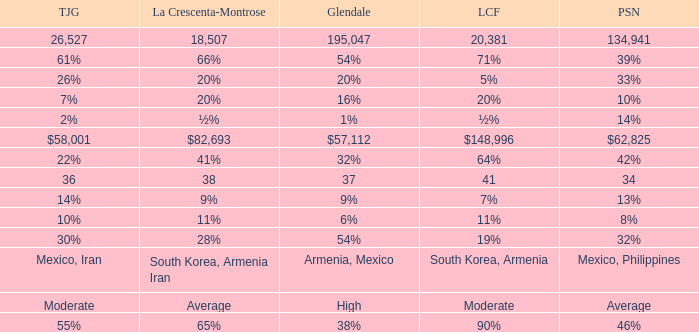What is the percentage of Glendale when La Canada Flintridge is 5%? 20%. 